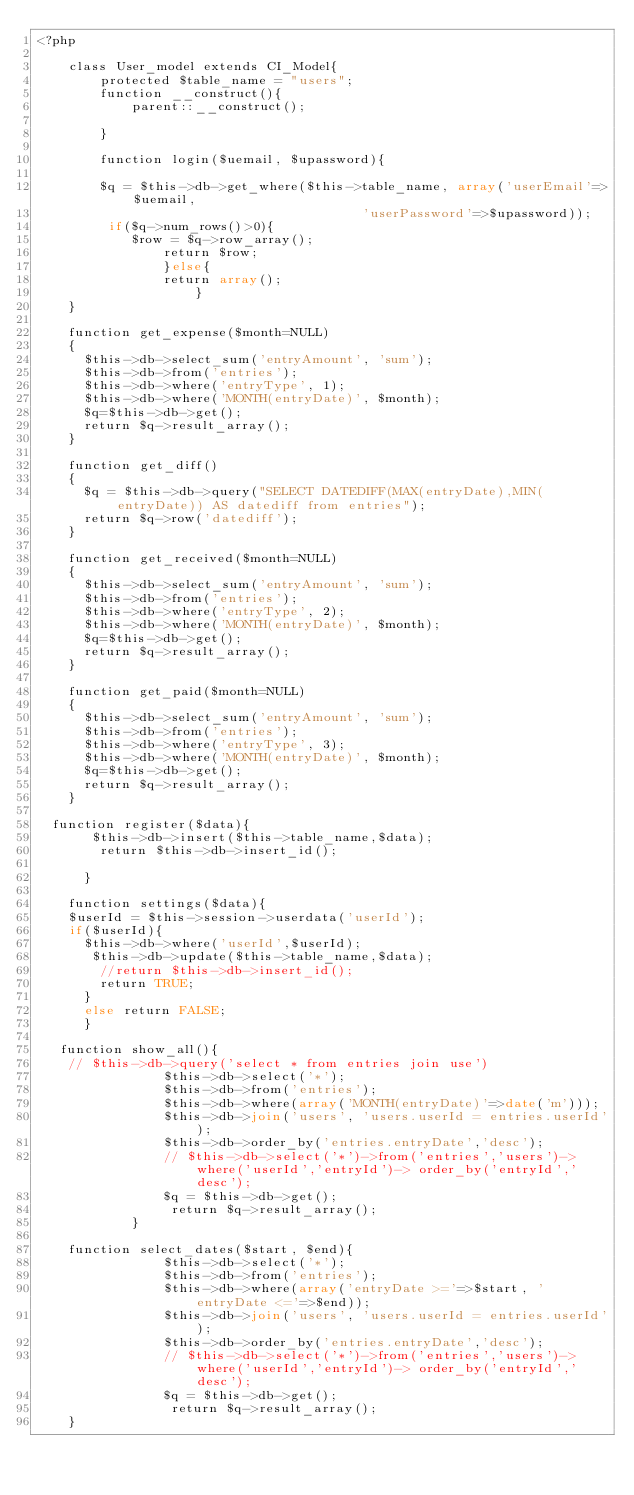<code> <loc_0><loc_0><loc_500><loc_500><_PHP_><?php
    
    class User_model extends CI_Model{
        protected $table_name = "users";
        function __construct(){
            parent::__construct();
            
        }
        
        function login($uemail, $upassword){
        
        $q = $this->db->get_where($this->table_name, array('userEmail'=>$uemail,
                                         'userPassword'=>$upassword));
         if($q->num_rows()>0){
            $row = $q->row_array();
                return $row;
                }else{
                return array();
                    }
    }

    function get_expense($month=NULL)
    {
      $this->db->select_sum('entryAmount', 'sum');
      $this->db->from('entries');
      $this->db->where('entryType', 1);      
      $this->db->where('MONTH(entryDate)', $month);      
      $q=$this->db->get();
      return $q->result_array();
    }

    function get_diff()
    {
      $q = $this->db->query("SELECT DATEDIFF(MAX(entryDate),MIN(entryDate)) AS datediff from entries");
      return $q->row('datediff');
    }    

    function get_received($month=NULL)
    {
      $this->db->select_sum('entryAmount', 'sum');
      $this->db->from('entries');
      $this->db->where('entryType', 2);      
      $this->db->where('MONTH(entryDate)', $month);      
      $q=$this->db->get();
      return $q->result_array();
    }

    function get_paid($month=NULL)
    {
      $this->db->select_sum('entryAmount', 'sum');
      $this->db->from('entries');
      $this->db->where('entryType', 3);      
      $this->db->where('MONTH(entryDate)', $month);      
      $q=$this->db->get();
      return $q->result_array();
    }
	
	function register($data){
			 $this->db->insert($this->table_name,$data);
			  return $this->db->insert_id();
				
			}
			
		function settings($data){
		$userId = $this->session->userdata('userId');
		if($userId){
			$this->db->where('userId',$userId);
			 $this->db->update($this->table_name,$data);
			  //return $this->db->insert_id();
			  return TRUE;
			}
			else return FALSE;
			}

	 function show_all(){
    // $this->db->query('select * from entries join use')
                $this->db->select('*');
                $this->db->from('entries');
                $this->db->where(array('MONTH(entryDate)'=>date('m')));
                $this->db->join('users', 'users.userId = entries.userId');                
                $this->db->order_by('entries.entryDate','desc');
                // $this->db->select('*')->from('entries','users')->where('userId','entryId')->	order_by('entryId','desc');
                $q = $this->db->get();
                 return $q->result_array();
            }

    function select_dates($start, $end){                
                $this->db->select('*');
                $this->db->from('entries');
                $this->db->where(array('entryDate >='=>$start, 'entryDate <='=>$end));
                $this->db->join('users', 'users.userId = entries.userId');                
                $this->db->order_by('entries.entryDate','desc');
                // $this->db->select('*')->from('entries','users')->where('userId','entryId')-> order_by('entryId','desc');
                $q = $this->db->get();
                 return $q->result_array();
    }
</code> 